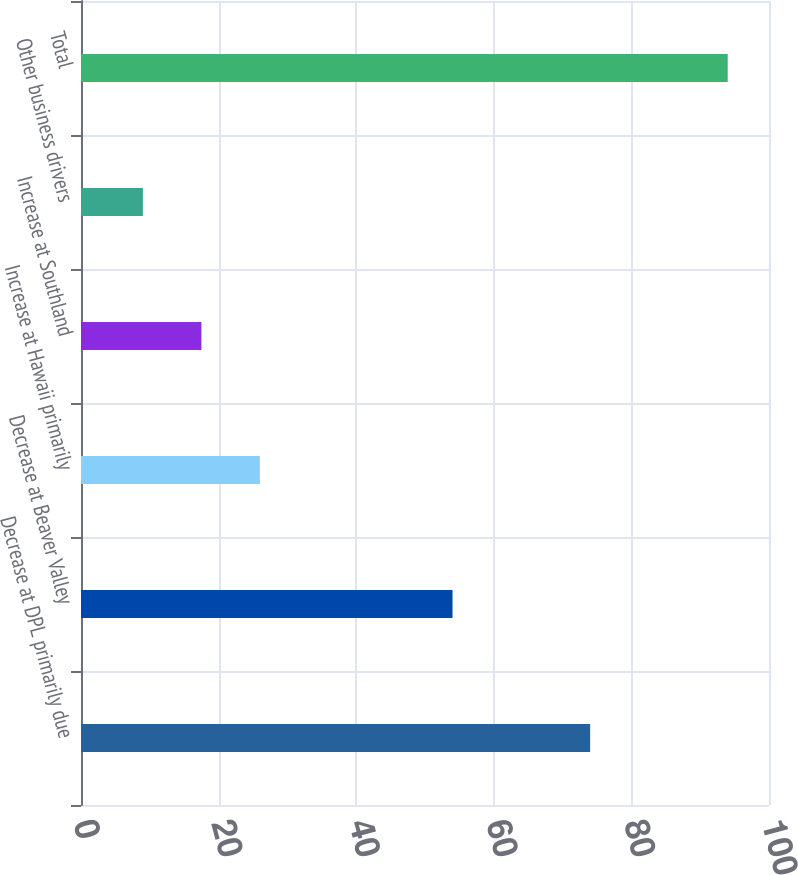<chart> <loc_0><loc_0><loc_500><loc_500><bar_chart><fcel>Decrease at DPL primarily due<fcel>Decrease at Beaver Valley<fcel>Increase at Hawaii primarily<fcel>Increase at Southland<fcel>Other business drivers<fcel>Total<nl><fcel>74<fcel>54<fcel>26<fcel>17.5<fcel>9<fcel>94<nl></chart> 